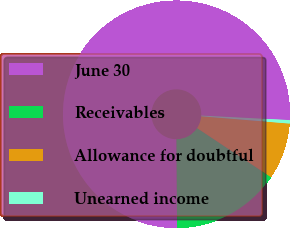Convert chart to OTSL. <chart><loc_0><loc_0><loc_500><loc_500><pie_chart><fcel>June 30<fcel>Receivables<fcel>Allowance for doubtful<fcel>Unearned income<nl><fcel>75.92%<fcel>15.57%<fcel>8.03%<fcel>0.48%<nl></chart> 